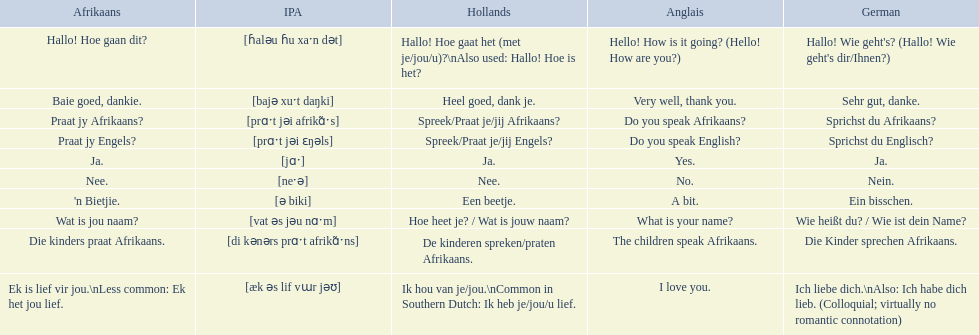How do you say hello! how is it going? in afrikaans? Hallo! Hoe gaan dit?. How do you say very well, thank you in afrikaans? Baie goed, dankie. I'm looking to parse the entire table for insights. Could you assist me with that? {'header': ['Afrikaans', 'IPA', 'Hollands', 'Anglais', 'German'], 'rows': [['Hallo! Hoe gaan dit?', '[ɦaləu ɦu xaˑn dət]', 'Hallo! Hoe gaat het (met je/jou/u)?\\nAlso used: Hallo! Hoe is het?', 'Hello! How is it going? (Hello! How are you?)', "Hallo! Wie geht's? (Hallo! Wie geht's dir/Ihnen?)"], ['Baie goed, dankie.', '[bajə xuˑt daŋki]', 'Heel goed, dank je.', 'Very well, thank you.', 'Sehr gut, danke.'], ['Praat jy Afrikaans?', '[prɑˑt jəi afrikɑ̃ˑs]', 'Spreek/Praat je/jij Afrikaans?', 'Do you speak Afrikaans?', 'Sprichst du Afrikaans?'], ['Praat jy Engels?', '[prɑˑt jəi ɛŋəls]', 'Spreek/Praat je/jij Engels?', 'Do you speak English?', 'Sprichst du Englisch?'], ['Ja.', '[jɑˑ]', 'Ja.', 'Yes.', 'Ja.'], ['Nee.', '[neˑə]', 'Nee.', 'No.', 'Nein.'], ["'n Bietjie.", '[ə biki]', 'Een beetje.', 'A bit.', 'Ein bisschen.'], ['Wat is jou naam?', '[vat əs jəu nɑˑm]', 'Hoe heet je? / Wat is jouw naam?', 'What is your name?', 'Wie heißt du? / Wie ist dein Name?'], ['Die kinders praat Afrikaans.', '[di kənərs prɑˑt afrikɑ̃ˑns]', 'De kinderen spreken/praten Afrikaans.', 'The children speak Afrikaans.', 'Die Kinder sprechen Afrikaans.'], ['Ek is lief vir jou.\\nLess common: Ek het jou lief.', '[æk əs lif vɯr jəʊ]', 'Ik hou van je/jou.\\nCommon in Southern Dutch: Ik heb je/jou/u lief.', 'I love you.', 'Ich liebe dich.\\nAlso: Ich habe dich lieb. (Colloquial; virtually no romantic connotation)']]} How would you say do you speak afrikaans? in afrikaans? Praat jy Afrikaans?. 